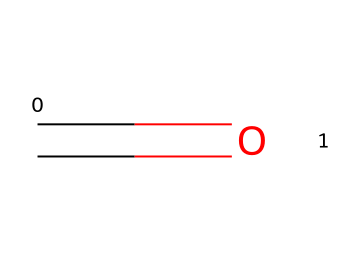What is the chemical name represented by the SMILES? The SMILES representation indicates a compound with a carbonyl group (C=O) attached to a carbon atom, which identifies it as formaldehyde.
Answer: formaldehyde How many carbon atoms are in this molecule? Analyzing the SMILES shows one carbon atom (C) present which is significant for the molecular structure.
Answer: 1 What type of bond is present in this chemical structure? The SMILES notation shows a double bond (indicated by the "=" between C and O), which is characteristic of the carbonyl functional group.
Answer: double bond What is the primary hazard associated with formaldehyde? Formaldehyde is considered a hazardous chemical mainly due to its classification as a carcinogen, which poses serious health risks upon exposure.
Answer: carcinogen What functional group is represented in this molecule? The C=O structure indicates a carbonyl group, which is essential in categorizing some organic compounds, such as aldehydes and ketones.
Answer: carbonyl group What is the typical state of formaldehyde at room temperature? Given formaldehyde's volatility and low boiling point, it typically exists as a gas at room temperature under standard conditions.
Answer: gas Why is this chemical used as a preservative? Formaldehyde's preservative properties stem from its ability to cross-link proteins in biological tissues, effectively preventing decay and microbial growth.
Answer: cross-linking proteins 